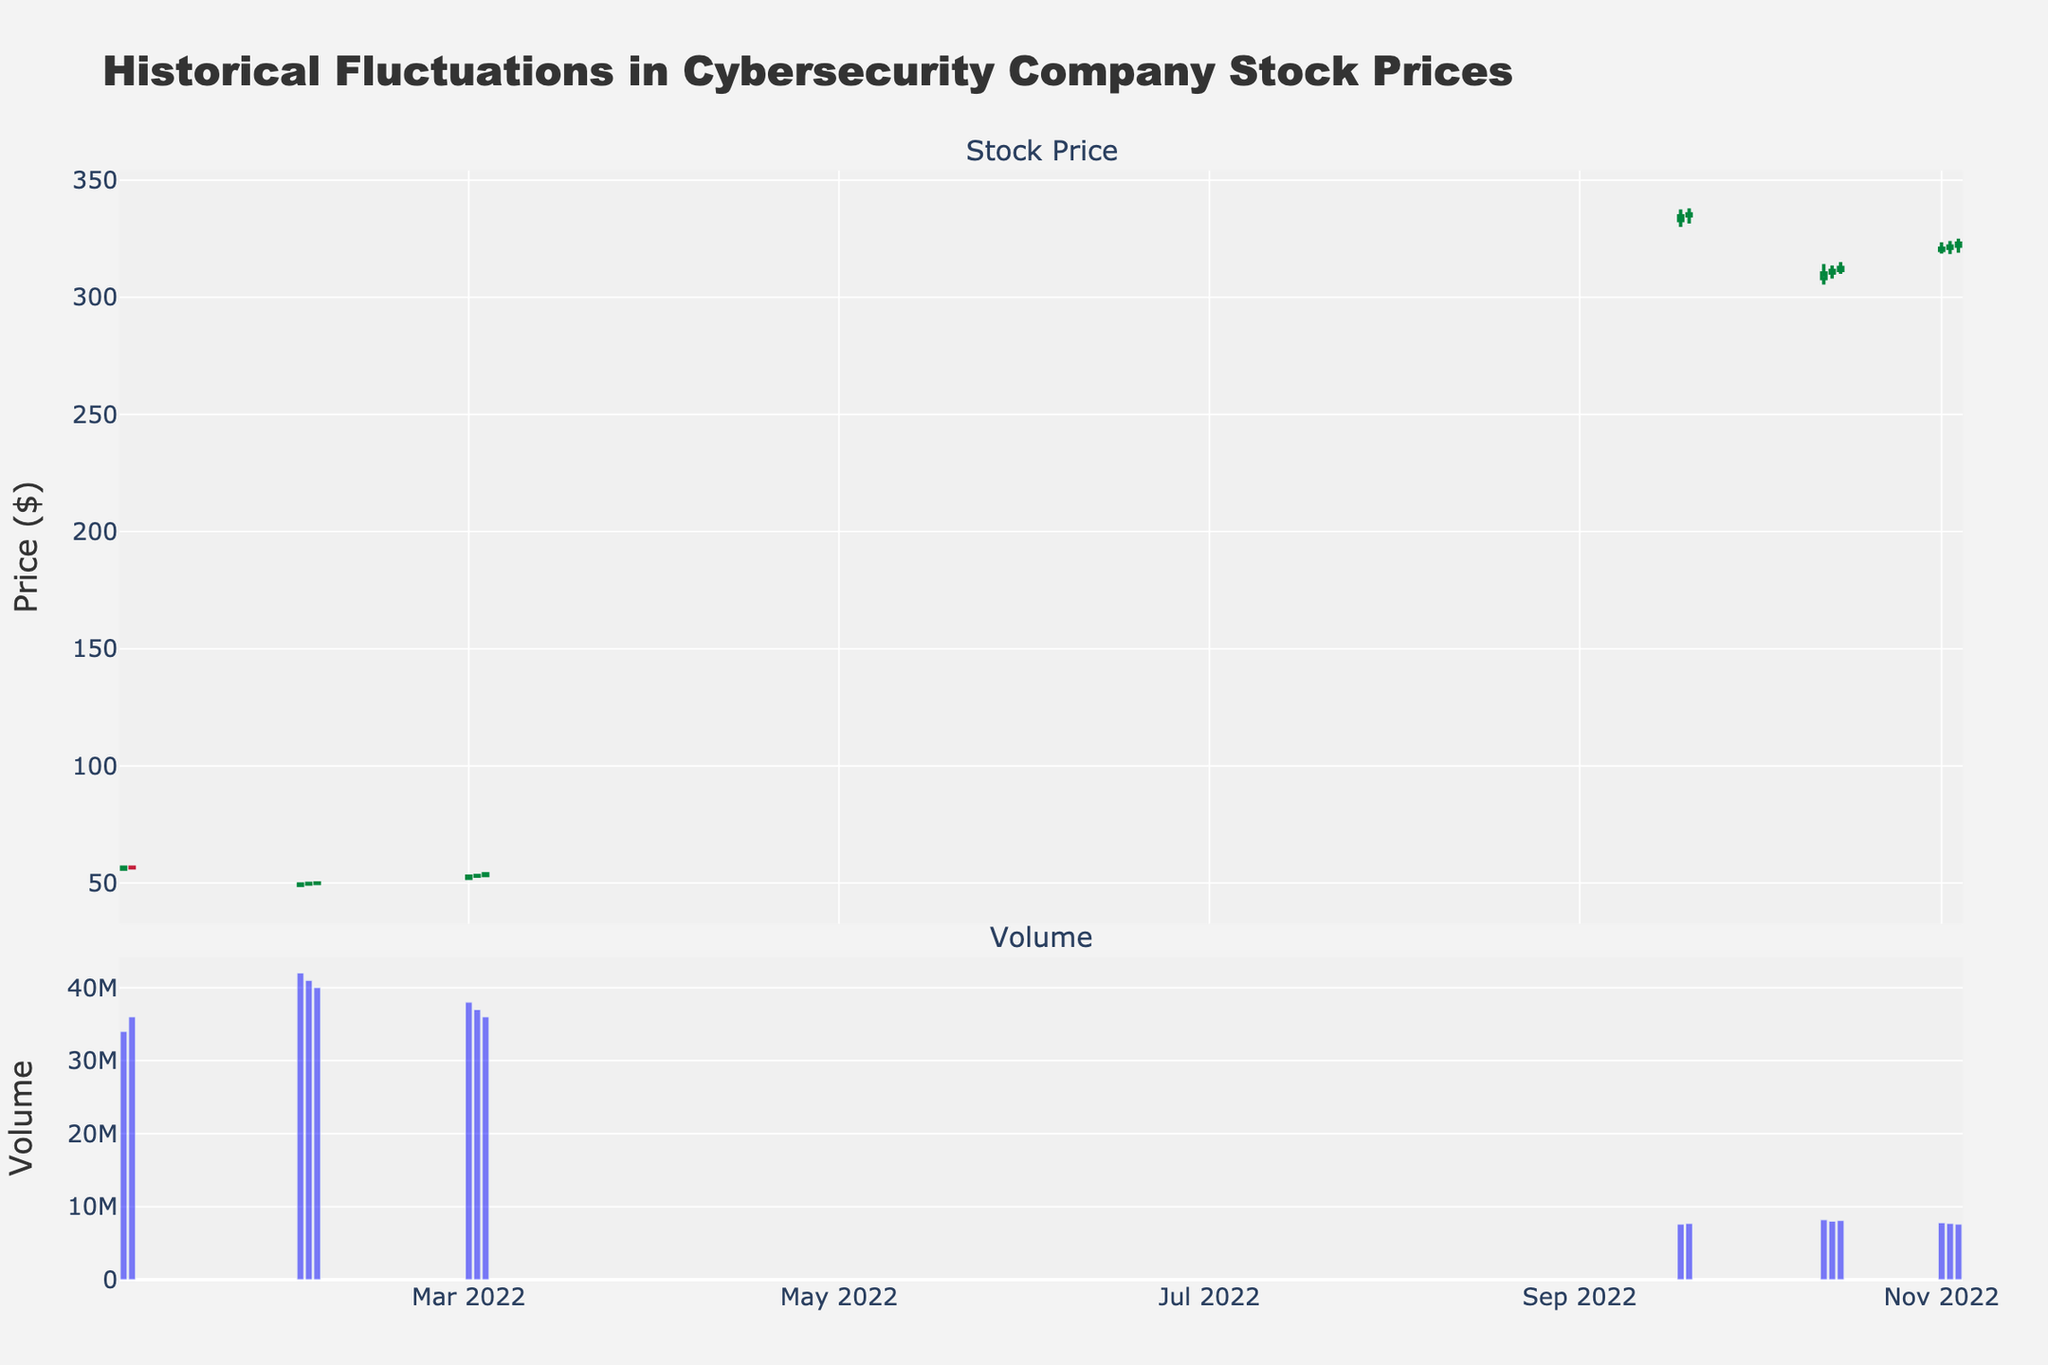Which cybersecurity company's stock experienced the highest price during the provided dates? By examining the candlestick traces, the highest price was reached by the stock 'FTNT' (Fortinet) on September 20, 2022, where the high was 338.00.
Answer: FTNT on September 20, 2022 How did the volume of 'CSCO' stocks change from January 2, 2022, to January 3, 2022? By comparing the volume bars beneath the candlestick traces for these dates, the volume increased from 32 million on January 2 to 34 million on January 3.
Answer: Volume increased What is the overall trend in the 'CSCO' stock prices from January 2, 2022, to January 4, 2022? The candlestick pattern for 'CSCO' shows 'CSCO' started at $55.30 on January 2, and closes at $56.50 on January 4, showing an overall increasing trend.
Answer: Increasing trend On which date did 'FTNT' have its lowest opening price based on the provided data? By examining the candlestick traces specifically for 'FTNT', the date with the lowest opening price was October 12, 2022, with an opening price of $308.00.
Answer: October 12, 2022 Compare the closing prices of 'CSCO' and 'FTNT' on March 3, 2022, and November 3, 2022, respectively. Which stock closed higher? On March 3, 'CSCO' closed at $53.90. On November 3, 'FTNT' closed at $323.10. Therefore, 'FTNT' had a higher closing price.
Answer: FTNT closed higher What is the difference between the high and low prices of 'FTNT' on October 13, 2022? The high price on October 13, 2022, was 313.60, and the low was 308.00. The difference is calculated as 313.60 - 308.00 = 5.60.
Answer: 5.60 During which date range did 'CSCO' experience its sharpest drop, and what was the opening and closing price on these dates? By reading the candlestick traces, 'CSCO' experienced its sharpest drop from February 1, 2022 (49.00 open) to February 2, 2022 (49.80 close). The opening price on February 1 was 49.00, and the closing price on February 3 was 50.00.
Answer: February 1, 2022, to February 3, 2022 Calculate the average closing price of 'CSCO' for the first three days in January 2022. The closing prices are 55.90 (Jan 2), 56.75 (Jan 3), and 56.50 (Jan 4). The average is (55.90 + 56.75 + 56.50) / 3 = 56.38.
Answer: 56.38 